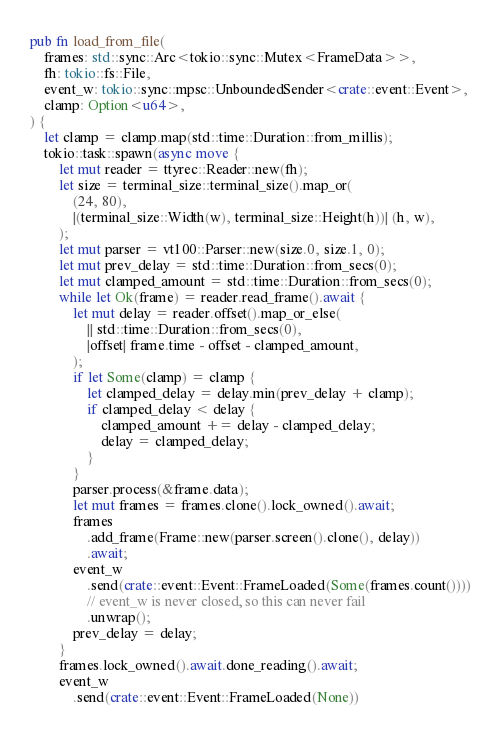<code> <loc_0><loc_0><loc_500><loc_500><_Rust_>
pub fn load_from_file(
    frames: std::sync::Arc<tokio::sync::Mutex<FrameData>>,
    fh: tokio::fs::File,
    event_w: tokio::sync::mpsc::UnboundedSender<crate::event::Event>,
    clamp: Option<u64>,
) {
    let clamp = clamp.map(std::time::Duration::from_millis);
    tokio::task::spawn(async move {
        let mut reader = ttyrec::Reader::new(fh);
        let size = terminal_size::terminal_size().map_or(
            (24, 80),
            |(terminal_size::Width(w), terminal_size::Height(h))| (h, w),
        );
        let mut parser = vt100::Parser::new(size.0, size.1, 0);
        let mut prev_delay = std::time::Duration::from_secs(0);
        let mut clamped_amount = std::time::Duration::from_secs(0);
        while let Ok(frame) = reader.read_frame().await {
            let mut delay = reader.offset().map_or_else(
                || std::time::Duration::from_secs(0),
                |offset| frame.time - offset - clamped_amount,
            );
            if let Some(clamp) = clamp {
                let clamped_delay = delay.min(prev_delay + clamp);
                if clamped_delay < delay {
                    clamped_amount += delay - clamped_delay;
                    delay = clamped_delay;
                }
            }
            parser.process(&frame.data);
            let mut frames = frames.clone().lock_owned().await;
            frames
                .add_frame(Frame::new(parser.screen().clone(), delay))
                .await;
            event_w
                .send(crate::event::Event::FrameLoaded(Some(frames.count())))
                // event_w is never closed, so this can never fail
                .unwrap();
            prev_delay = delay;
        }
        frames.lock_owned().await.done_reading().await;
        event_w
            .send(crate::event::Event::FrameLoaded(None))</code> 